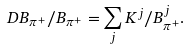Convert formula to latex. <formula><loc_0><loc_0><loc_500><loc_500>\ D B _ { \pi ^ { + } } / B _ { \pi ^ { + } } = \sum _ { j } K ^ { j } / B _ { \pi ^ { + } } ^ { j } .</formula> 